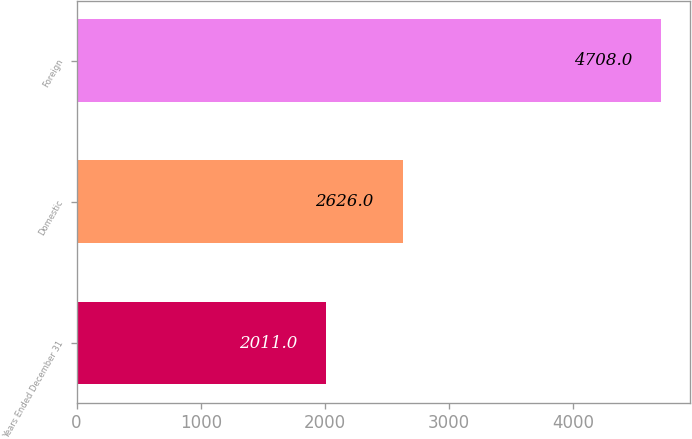Convert chart to OTSL. <chart><loc_0><loc_0><loc_500><loc_500><bar_chart><fcel>Years Ended December 31<fcel>Domestic<fcel>Foreign<nl><fcel>2011<fcel>2626<fcel>4708<nl></chart> 